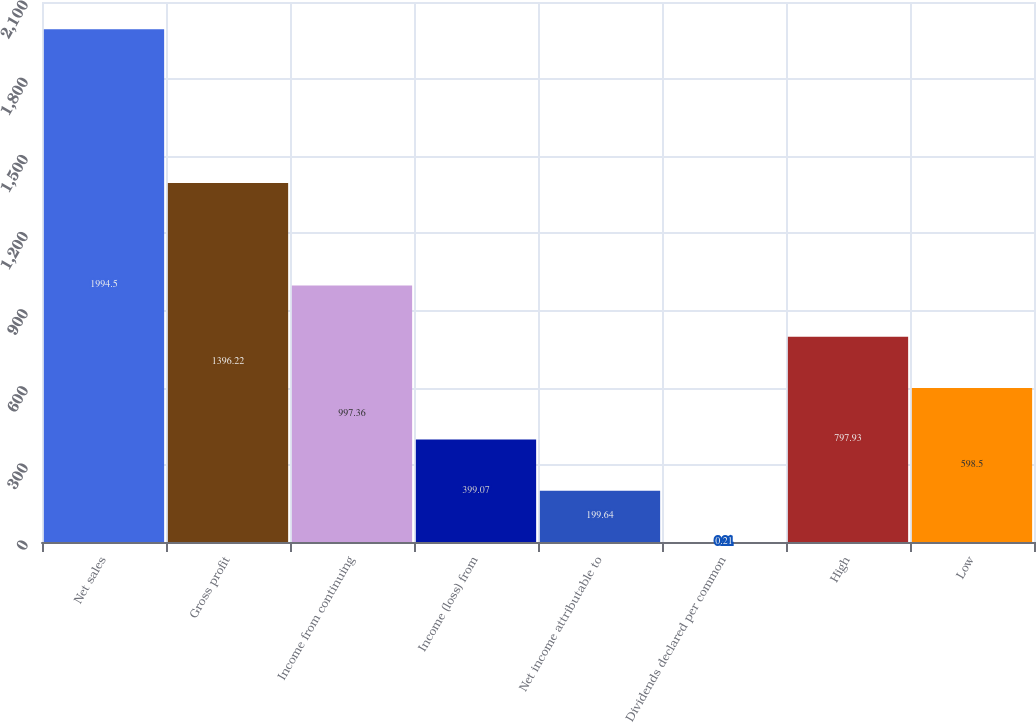<chart> <loc_0><loc_0><loc_500><loc_500><bar_chart><fcel>Net sales<fcel>Gross profit<fcel>Income from continuing<fcel>Income (loss) from<fcel>Net income attributable to<fcel>Dividends declared per common<fcel>High<fcel>Low<nl><fcel>1994.5<fcel>1396.22<fcel>997.36<fcel>399.07<fcel>199.64<fcel>0.21<fcel>797.93<fcel>598.5<nl></chart> 